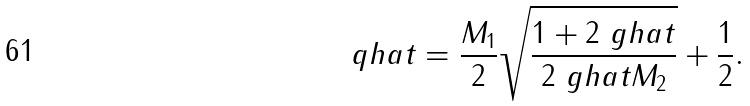Convert formula to latex. <formula><loc_0><loc_0><loc_500><loc_500>\ q h a t & = \frac { M _ { 1 } } { 2 } \sqrt { \frac { 1 + 2 \ g h a t } { 2 \ g h a t M _ { 2 } } } + \frac { 1 } { 2 } .</formula> 